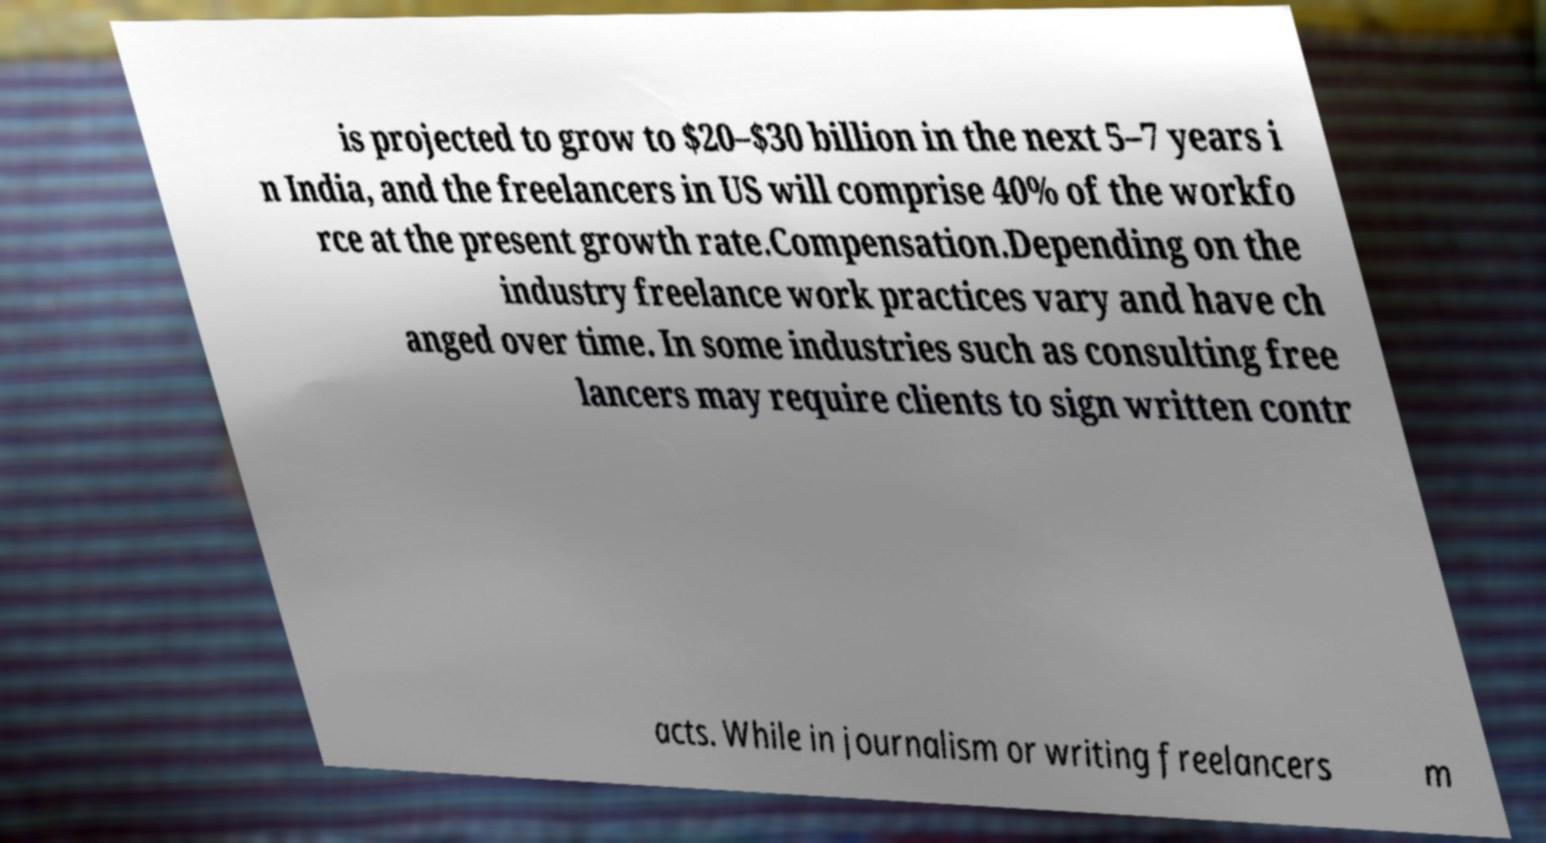Please identify and transcribe the text found in this image. is projected to grow to $20–$30 billion in the next 5–7 years i n India, and the freelancers in US will comprise 40% of the workfo rce at the present growth rate.Compensation.Depending on the industry freelance work practices vary and have ch anged over time. In some industries such as consulting free lancers may require clients to sign written contr acts. While in journalism or writing freelancers m 